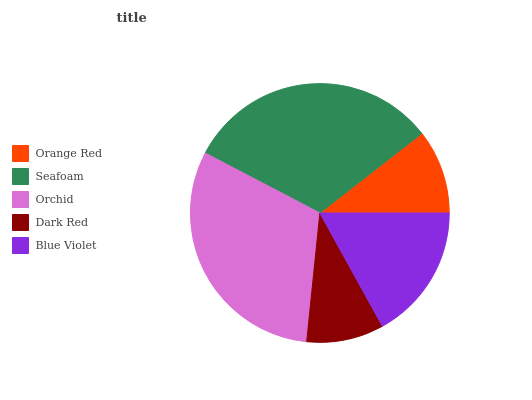Is Dark Red the minimum?
Answer yes or no. Yes. Is Seafoam the maximum?
Answer yes or no. Yes. Is Orchid the minimum?
Answer yes or no. No. Is Orchid the maximum?
Answer yes or no. No. Is Seafoam greater than Orchid?
Answer yes or no. Yes. Is Orchid less than Seafoam?
Answer yes or no. Yes. Is Orchid greater than Seafoam?
Answer yes or no. No. Is Seafoam less than Orchid?
Answer yes or no. No. Is Blue Violet the high median?
Answer yes or no. Yes. Is Blue Violet the low median?
Answer yes or no. Yes. Is Orange Red the high median?
Answer yes or no. No. Is Orange Red the low median?
Answer yes or no. No. 